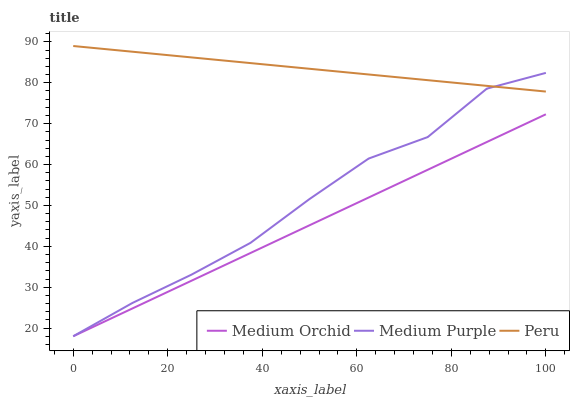Does Medium Orchid have the minimum area under the curve?
Answer yes or no. Yes. Does Peru have the maximum area under the curve?
Answer yes or no. Yes. Does Peru have the minimum area under the curve?
Answer yes or no. No. Does Medium Orchid have the maximum area under the curve?
Answer yes or no. No. Is Medium Orchid the smoothest?
Answer yes or no. Yes. Is Medium Purple the roughest?
Answer yes or no. Yes. Is Peru the smoothest?
Answer yes or no. No. Is Peru the roughest?
Answer yes or no. No. Does Medium Purple have the lowest value?
Answer yes or no. Yes. Does Peru have the lowest value?
Answer yes or no. No. Does Peru have the highest value?
Answer yes or no. Yes. Does Medium Orchid have the highest value?
Answer yes or no. No. Is Medium Orchid less than Peru?
Answer yes or no. Yes. Is Peru greater than Medium Orchid?
Answer yes or no. Yes. Does Medium Purple intersect Medium Orchid?
Answer yes or no. Yes. Is Medium Purple less than Medium Orchid?
Answer yes or no. No. Is Medium Purple greater than Medium Orchid?
Answer yes or no. No. Does Medium Orchid intersect Peru?
Answer yes or no. No. 